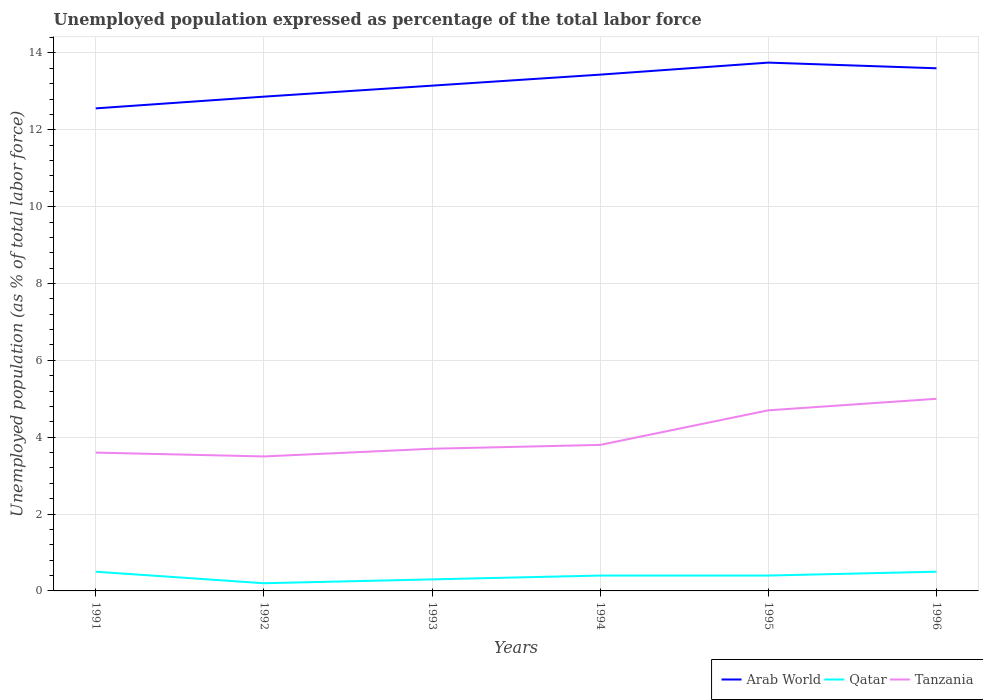How many different coloured lines are there?
Provide a short and direct response. 3. Across all years, what is the maximum unemployment in in Tanzania?
Provide a short and direct response. 3.5. In which year was the unemployment in in Tanzania maximum?
Your answer should be very brief. 1992. What is the total unemployment in in Tanzania in the graph?
Your answer should be compact. 0.1. What is the difference between the highest and the second highest unemployment in in Qatar?
Your answer should be compact. 0.3. What is the difference between the highest and the lowest unemployment in in Arab World?
Your answer should be very brief. 3. Is the unemployment in in Tanzania strictly greater than the unemployment in in Qatar over the years?
Offer a very short reply. No. How many lines are there?
Keep it short and to the point. 3. What is the difference between two consecutive major ticks on the Y-axis?
Offer a very short reply. 2. Does the graph contain any zero values?
Your answer should be very brief. No. What is the title of the graph?
Keep it short and to the point. Unemployed population expressed as percentage of the total labor force. Does "Suriname" appear as one of the legend labels in the graph?
Offer a very short reply. No. What is the label or title of the Y-axis?
Provide a short and direct response. Unemployed population (as % of total labor force). What is the Unemployed population (as % of total labor force) of Arab World in 1991?
Provide a short and direct response. 12.56. What is the Unemployed population (as % of total labor force) in Qatar in 1991?
Offer a terse response. 0.5. What is the Unemployed population (as % of total labor force) in Tanzania in 1991?
Offer a very short reply. 3.6. What is the Unemployed population (as % of total labor force) of Arab World in 1992?
Provide a succinct answer. 12.86. What is the Unemployed population (as % of total labor force) of Qatar in 1992?
Your response must be concise. 0.2. What is the Unemployed population (as % of total labor force) in Arab World in 1993?
Offer a very short reply. 13.15. What is the Unemployed population (as % of total labor force) of Qatar in 1993?
Your response must be concise. 0.3. What is the Unemployed population (as % of total labor force) in Tanzania in 1993?
Give a very brief answer. 3.7. What is the Unemployed population (as % of total labor force) in Arab World in 1994?
Keep it short and to the point. 13.44. What is the Unemployed population (as % of total labor force) in Qatar in 1994?
Offer a very short reply. 0.4. What is the Unemployed population (as % of total labor force) of Tanzania in 1994?
Your answer should be compact. 3.8. What is the Unemployed population (as % of total labor force) in Arab World in 1995?
Provide a short and direct response. 13.75. What is the Unemployed population (as % of total labor force) in Qatar in 1995?
Your response must be concise. 0.4. What is the Unemployed population (as % of total labor force) of Tanzania in 1995?
Your response must be concise. 4.7. What is the Unemployed population (as % of total labor force) of Arab World in 1996?
Offer a terse response. 13.6. What is the Unemployed population (as % of total labor force) of Qatar in 1996?
Provide a succinct answer. 0.5. Across all years, what is the maximum Unemployed population (as % of total labor force) in Arab World?
Ensure brevity in your answer.  13.75. Across all years, what is the maximum Unemployed population (as % of total labor force) of Qatar?
Provide a succinct answer. 0.5. Across all years, what is the maximum Unemployed population (as % of total labor force) of Tanzania?
Keep it short and to the point. 5. Across all years, what is the minimum Unemployed population (as % of total labor force) of Arab World?
Offer a terse response. 12.56. Across all years, what is the minimum Unemployed population (as % of total labor force) in Qatar?
Keep it short and to the point. 0.2. Across all years, what is the minimum Unemployed population (as % of total labor force) in Tanzania?
Give a very brief answer. 3.5. What is the total Unemployed population (as % of total labor force) in Arab World in the graph?
Your answer should be very brief. 79.36. What is the total Unemployed population (as % of total labor force) in Qatar in the graph?
Offer a very short reply. 2.3. What is the total Unemployed population (as % of total labor force) in Tanzania in the graph?
Provide a succinct answer. 24.3. What is the difference between the Unemployed population (as % of total labor force) in Arab World in 1991 and that in 1992?
Provide a short and direct response. -0.31. What is the difference between the Unemployed population (as % of total labor force) in Qatar in 1991 and that in 1992?
Ensure brevity in your answer.  0.3. What is the difference between the Unemployed population (as % of total labor force) in Tanzania in 1991 and that in 1992?
Ensure brevity in your answer.  0.1. What is the difference between the Unemployed population (as % of total labor force) of Arab World in 1991 and that in 1993?
Your answer should be compact. -0.59. What is the difference between the Unemployed population (as % of total labor force) of Qatar in 1991 and that in 1993?
Your response must be concise. 0.2. What is the difference between the Unemployed population (as % of total labor force) of Tanzania in 1991 and that in 1993?
Give a very brief answer. -0.1. What is the difference between the Unemployed population (as % of total labor force) in Arab World in 1991 and that in 1994?
Offer a very short reply. -0.88. What is the difference between the Unemployed population (as % of total labor force) in Tanzania in 1991 and that in 1994?
Your response must be concise. -0.2. What is the difference between the Unemployed population (as % of total labor force) in Arab World in 1991 and that in 1995?
Offer a terse response. -1.19. What is the difference between the Unemployed population (as % of total labor force) of Arab World in 1991 and that in 1996?
Make the answer very short. -1.04. What is the difference between the Unemployed population (as % of total labor force) in Arab World in 1992 and that in 1993?
Offer a very short reply. -0.29. What is the difference between the Unemployed population (as % of total labor force) in Tanzania in 1992 and that in 1993?
Make the answer very short. -0.2. What is the difference between the Unemployed population (as % of total labor force) of Arab World in 1992 and that in 1994?
Your response must be concise. -0.57. What is the difference between the Unemployed population (as % of total labor force) in Tanzania in 1992 and that in 1994?
Ensure brevity in your answer.  -0.3. What is the difference between the Unemployed population (as % of total labor force) in Arab World in 1992 and that in 1995?
Your response must be concise. -0.89. What is the difference between the Unemployed population (as % of total labor force) in Arab World in 1992 and that in 1996?
Give a very brief answer. -0.74. What is the difference between the Unemployed population (as % of total labor force) of Qatar in 1992 and that in 1996?
Your response must be concise. -0.3. What is the difference between the Unemployed population (as % of total labor force) of Tanzania in 1992 and that in 1996?
Provide a short and direct response. -1.5. What is the difference between the Unemployed population (as % of total labor force) in Arab World in 1993 and that in 1994?
Ensure brevity in your answer.  -0.29. What is the difference between the Unemployed population (as % of total labor force) in Qatar in 1993 and that in 1994?
Offer a terse response. -0.1. What is the difference between the Unemployed population (as % of total labor force) in Tanzania in 1993 and that in 1994?
Offer a very short reply. -0.1. What is the difference between the Unemployed population (as % of total labor force) of Arab World in 1993 and that in 1995?
Ensure brevity in your answer.  -0.6. What is the difference between the Unemployed population (as % of total labor force) of Qatar in 1993 and that in 1995?
Provide a succinct answer. -0.1. What is the difference between the Unemployed population (as % of total labor force) in Arab World in 1993 and that in 1996?
Your response must be concise. -0.45. What is the difference between the Unemployed population (as % of total labor force) of Arab World in 1994 and that in 1995?
Offer a terse response. -0.31. What is the difference between the Unemployed population (as % of total labor force) of Qatar in 1994 and that in 1995?
Your response must be concise. 0. What is the difference between the Unemployed population (as % of total labor force) of Arab World in 1994 and that in 1996?
Keep it short and to the point. -0.17. What is the difference between the Unemployed population (as % of total labor force) of Qatar in 1994 and that in 1996?
Ensure brevity in your answer.  -0.1. What is the difference between the Unemployed population (as % of total labor force) of Arab World in 1995 and that in 1996?
Your response must be concise. 0.15. What is the difference between the Unemployed population (as % of total labor force) of Qatar in 1995 and that in 1996?
Your answer should be very brief. -0.1. What is the difference between the Unemployed population (as % of total labor force) of Tanzania in 1995 and that in 1996?
Offer a terse response. -0.3. What is the difference between the Unemployed population (as % of total labor force) in Arab World in 1991 and the Unemployed population (as % of total labor force) in Qatar in 1992?
Provide a succinct answer. 12.36. What is the difference between the Unemployed population (as % of total labor force) in Arab World in 1991 and the Unemployed population (as % of total labor force) in Tanzania in 1992?
Provide a succinct answer. 9.06. What is the difference between the Unemployed population (as % of total labor force) of Qatar in 1991 and the Unemployed population (as % of total labor force) of Tanzania in 1992?
Your response must be concise. -3. What is the difference between the Unemployed population (as % of total labor force) of Arab World in 1991 and the Unemployed population (as % of total labor force) of Qatar in 1993?
Keep it short and to the point. 12.26. What is the difference between the Unemployed population (as % of total labor force) in Arab World in 1991 and the Unemployed population (as % of total labor force) in Tanzania in 1993?
Ensure brevity in your answer.  8.86. What is the difference between the Unemployed population (as % of total labor force) of Qatar in 1991 and the Unemployed population (as % of total labor force) of Tanzania in 1993?
Your response must be concise. -3.2. What is the difference between the Unemployed population (as % of total labor force) of Arab World in 1991 and the Unemployed population (as % of total labor force) of Qatar in 1994?
Keep it short and to the point. 12.16. What is the difference between the Unemployed population (as % of total labor force) in Arab World in 1991 and the Unemployed population (as % of total labor force) in Tanzania in 1994?
Ensure brevity in your answer.  8.76. What is the difference between the Unemployed population (as % of total labor force) in Qatar in 1991 and the Unemployed population (as % of total labor force) in Tanzania in 1994?
Offer a terse response. -3.3. What is the difference between the Unemployed population (as % of total labor force) in Arab World in 1991 and the Unemployed population (as % of total labor force) in Qatar in 1995?
Provide a succinct answer. 12.16. What is the difference between the Unemployed population (as % of total labor force) of Arab World in 1991 and the Unemployed population (as % of total labor force) of Tanzania in 1995?
Give a very brief answer. 7.86. What is the difference between the Unemployed population (as % of total labor force) of Qatar in 1991 and the Unemployed population (as % of total labor force) of Tanzania in 1995?
Your response must be concise. -4.2. What is the difference between the Unemployed population (as % of total labor force) in Arab World in 1991 and the Unemployed population (as % of total labor force) in Qatar in 1996?
Provide a succinct answer. 12.06. What is the difference between the Unemployed population (as % of total labor force) in Arab World in 1991 and the Unemployed population (as % of total labor force) in Tanzania in 1996?
Your answer should be compact. 7.56. What is the difference between the Unemployed population (as % of total labor force) in Arab World in 1992 and the Unemployed population (as % of total labor force) in Qatar in 1993?
Keep it short and to the point. 12.56. What is the difference between the Unemployed population (as % of total labor force) in Arab World in 1992 and the Unemployed population (as % of total labor force) in Tanzania in 1993?
Provide a short and direct response. 9.16. What is the difference between the Unemployed population (as % of total labor force) of Qatar in 1992 and the Unemployed population (as % of total labor force) of Tanzania in 1993?
Ensure brevity in your answer.  -3.5. What is the difference between the Unemployed population (as % of total labor force) of Arab World in 1992 and the Unemployed population (as % of total labor force) of Qatar in 1994?
Provide a succinct answer. 12.46. What is the difference between the Unemployed population (as % of total labor force) of Arab World in 1992 and the Unemployed population (as % of total labor force) of Tanzania in 1994?
Your answer should be very brief. 9.06. What is the difference between the Unemployed population (as % of total labor force) of Qatar in 1992 and the Unemployed population (as % of total labor force) of Tanzania in 1994?
Provide a short and direct response. -3.6. What is the difference between the Unemployed population (as % of total labor force) in Arab World in 1992 and the Unemployed population (as % of total labor force) in Qatar in 1995?
Give a very brief answer. 12.46. What is the difference between the Unemployed population (as % of total labor force) in Arab World in 1992 and the Unemployed population (as % of total labor force) in Tanzania in 1995?
Provide a short and direct response. 8.16. What is the difference between the Unemployed population (as % of total labor force) of Arab World in 1992 and the Unemployed population (as % of total labor force) of Qatar in 1996?
Offer a very short reply. 12.36. What is the difference between the Unemployed population (as % of total labor force) of Arab World in 1992 and the Unemployed population (as % of total labor force) of Tanzania in 1996?
Give a very brief answer. 7.86. What is the difference between the Unemployed population (as % of total labor force) in Arab World in 1993 and the Unemployed population (as % of total labor force) in Qatar in 1994?
Ensure brevity in your answer.  12.75. What is the difference between the Unemployed population (as % of total labor force) in Arab World in 1993 and the Unemployed population (as % of total labor force) in Tanzania in 1994?
Your answer should be compact. 9.35. What is the difference between the Unemployed population (as % of total labor force) in Qatar in 1993 and the Unemployed population (as % of total labor force) in Tanzania in 1994?
Provide a succinct answer. -3.5. What is the difference between the Unemployed population (as % of total labor force) in Arab World in 1993 and the Unemployed population (as % of total labor force) in Qatar in 1995?
Offer a terse response. 12.75. What is the difference between the Unemployed population (as % of total labor force) in Arab World in 1993 and the Unemployed population (as % of total labor force) in Tanzania in 1995?
Your response must be concise. 8.45. What is the difference between the Unemployed population (as % of total labor force) in Qatar in 1993 and the Unemployed population (as % of total labor force) in Tanzania in 1995?
Make the answer very short. -4.4. What is the difference between the Unemployed population (as % of total labor force) in Arab World in 1993 and the Unemployed population (as % of total labor force) in Qatar in 1996?
Your answer should be compact. 12.65. What is the difference between the Unemployed population (as % of total labor force) in Arab World in 1993 and the Unemployed population (as % of total labor force) in Tanzania in 1996?
Offer a terse response. 8.15. What is the difference between the Unemployed population (as % of total labor force) of Arab World in 1994 and the Unemployed population (as % of total labor force) of Qatar in 1995?
Provide a succinct answer. 13.04. What is the difference between the Unemployed population (as % of total labor force) of Arab World in 1994 and the Unemployed population (as % of total labor force) of Tanzania in 1995?
Provide a succinct answer. 8.74. What is the difference between the Unemployed population (as % of total labor force) of Qatar in 1994 and the Unemployed population (as % of total labor force) of Tanzania in 1995?
Provide a short and direct response. -4.3. What is the difference between the Unemployed population (as % of total labor force) in Arab World in 1994 and the Unemployed population (as % of total labor force) in Qatar in 1996?
Keep it short and to the point. 12.94. What is the difference between the Unemployed population (as % of total labor force) in Arab World in 1994 and the Unemployed population (as % of total labor force) in Tanzania in 1996?
Keep it short and to the point. 8.44. What is the difference between the Unemployed population (as % of total labor force) in Arab World in 1995 and the Unemployed population (as % of total labor force) in Qatar in 1996?
Your response must be concise. 13.25. What is the difference between the Unemployed population (as % of total labor force) in Arab World in 1995 and the Unemployed population (as % of total labor force) in Tanzania in 1996?
Make the answer very short. 8.75. What is the difference between the Unemployed population (as % of total labor force) in Qatar in 1995 and the Unemployed population (as % of total labor force) in Tanzania in 1996?
Your answer should be compact. -4.6. What is the average Unemployed population (as % of total labor force) in Arab World per year?
Keep it short and to the point. 13.23. What is the average Unemployed population (as % of total labor force) of Qatar per year?
Your answer should be very brief. 0.38. What is the average Unemployed population (as % of total labor force) in Tanzania per year?
Offer a very short reply. 4.05. In the year 1991, what is the difference between the Unemployed population (as % of total labor force) in Arab World and Unemployed population (as % of total labor force) in Qatar?
Keep it short and to the point. 12.06. In the year 1991, what is the difference between the Unemployed population (as % of total labor force) in Arab World and Unemployed population (as % of total labor force) in Tanzania?
Give a very brief answer. 8.96. In the year 1992, what is the difference between the Unemployed population (as % of total labor force) in Arab World and Unemployed population (as % of total labor force) in Qatar?
Ensure brevity in your answer.  12.66. In the year 1992, what is the difference between the Unemployed population (as % of total labor force) in Arab World and Unemployed population (as % of total labor force) in Tanzania?
Keep it short and to the point. 9.36. In the year 1992, what is the difference between the Unemployed population (as % of total labor force) of Qatar and Unemployed population (as % of total labor force) of Tanzania?
Offer a very short reply. -3.3. In the year 1993, what is the difference between the Unemployed population (as % of total labor force) in Arab World and Unemployed population (as % of total labor force) in Qatar?
Ensure brevity in your answer.  12.85. In the year 1993, what is the difference between the Unemployed population (as % of total labor force) of Arab World and Unemployed population (as % of total labor force) of Tanzania?
Your answer should be compact. 9.45. In the year 1993, what is the difference between the Unemployed population (as % of total labor force) of Qatar and Unemployed population (as % of total labor force) of Tanzania?
Your answer should be very brief. -3.4. In the year 1994, what is the difference between the Unemployed population (as % of total labor force) of Arab World and Unemployed population (as % of total labor force) of Qatar?
Offer a terse response. 13.04. In the year 1994, what is the difference between the Unemployed population (as % of total labor force) of Arab World and Unemployed population (as % of total labor force) of Tanzania?
Provide a succinct answer. 9.64. In the year 1994, what is the difference between the Unemployed population (as % of total labor force) of Qatar and Unemployed population (as % of total labor force) of Tanzania?
Provide a succinct answer. -3.4. In the year 1995, what is the difference between the Unemployed population (as % of total labor force) of Arab World and Unemployed population (as % of total labor force) of Qatar?
Provide a succinct answer. 13.35. In the year 1995, what is the difference between the Unemployed population (as % of total labor force) of Arab World and Unemployed population (as % of total labor force) of Tanzania?
Provide a short and direct response. 9.05. In the year 1995, what is the difference between the Unemployed population (as % of total labor force) of Qatar and Unemployed population (as % of total labor force) of Tanzania?
Provide a succinct answer. -4.3. In the year 1996, what is the difference between the Unemployed population (as % of total labor force) in Arab World and Unemployed population (as % of total labor force) in Qatar?
Provide a succinct answer. 13.1. In the year 1996, what is the difference between the Unemployed population (as % of total labor force) of Arab World and Unemployed population (as % of total labor force) of Tanzania?
Your response must be concise. 8.6. What is the ratio of the Unemployed population (as % of total labor force) in Arab World in 1991 to that in 1992?
Keep it short and to the point. 0.98. What is the ratio of the Unemployed population (as % of total labor force) in Tanzania in 1991 to that in 1992?
Your response must be concise. 1.03. What is the ratio of the Unemployed population (as % of total labor force) in Arab World in 1991 to that in 1993?
Ensure brevity in your answer.  0.95. What is the ratio of the Unemployed population (as % of total labor force) in Tanzania in 1991 to that in 1993?
Keep it short and to the point. 0.97. What is the ratio of the Unemployed population (as % of total labor force) of Arab World in 1991 to that in 1994?
Offer a terse response. 0.93. What is the ratio of the Unemployed population (as % of total labor force) in Tanzania in 1991 to that in 1994?
Keep it short and to the point. 0.95. What is the ratio of the Unemployed population (as % of total labor force) in Arab World in 1991 to that in 1995?
Provide a short and direct response. 0.91. What is the ratio of the Unemployed population (as % of total labor force) in Qatar in 1991 to that in 1995?
Your answer should be very brief. 1.25. What is the ratio of the Unemployed population (as % of total labor force) in Tanzania in 1991 to that in 1995?
Provide a succinct answer. 0.77. What is the ratio of the Unemployed population (as % of total labor force) of Arab World in 1991 to that in 1996?
Make the answer very short. 0.92. What is the ratio of the Unemployed population (as % of total labor force) of Tanzania in 1991 to that in 1996?
Keep it short and to the point. 0.72. What is the ratio of the Unemployed population (as % of total labor force) in Arab World in 1992 to that in 1993?
Keep it short and to the point. 0.98. What is the ratio of the Unemployed population (as % of total labor force) of Qatar in 1992 to that in 1993?
Provide a succinct answer. 0.67. What is the ratio of the Unemployed population (as % of total labor force) of Tanzania in 1992 to that in 1993?
Your response must be concise. 0.95. What is the ratio of the Unemployed population (as % of total labor force) in Arab World in 1992 to that in 1994?
Provide a succinct answer. 0.96. What is the ratio of the Unemployed population (as % of total labor force) in Tanzania in 1992 to that in 1994?
Your response must be concise. 0.92. What is the ratio of the Unemployed population (as % of total labor force) of Arab World in 1992 to that in 1995?
Provide a short and direct response. 0.94. What is the ratio of the Unemployed population (as % of total labor force) in Qatar in 1992 to that in 1995?
Offer a very short reply. 0.5. What is the ratio of the Unemployed population (as % of total labor force) of Tanzania in 1992 to that in 1995?
Your answer should be very brief. 0.74. What is the ratio of the Unemployed population (as % of total labor force) in Arab World in 1992 to that in 1996?
Ensure brevity in your answer.  0.95. What is the ratio of the Unemployed population (as % of total labor force) in Tanzania in 1992 to that in 1996?
Offer a very short reply. 0.7. What is the ratio of the Unemployed population (as % of total labor force) in Arab World in 1993 to that in 1994?
Your response must be concise. 0.98. What is the ratio of the Unemployed population (as % of total labor force) of Qatar in 1993 to that in 1994?
Your answer should be very brief. 0.75. What is the ratio of the Unemployed population (as % of total labor force) of Tanzania in 1993 to that in 1994?
Provide a succinct answer. 0.97. What is the ratio of the Unemployed population (as % of total labor force) in Arab World in 1993 to that in 1995?
Offer a terse response. 0.96. What is the ratio of the Unemployed population (as % of total labor force) of Qatar in 1993 to that in 1995?
Offer a very short reply. 0.75. What is the ratio of the Unemployed population (as % of total labor force) of Tanzania in 1993 to that in 1995?
Provide a succinct answer. 0.79. What is the ratio of the Unemployed population (as % of total labor force) of Arab World in 1993 to that in 1996?
Provide a succinct answer. 0.97. What is the ratio of the Unemployed population (as % of total labor force) in Qatar in 1993 to that in 1996?
Provide a short and direct response. 0.6. What is the ratio of the Unemployed population (as % of total labor force) in Tanzania in 1993 to that in 1996?
Your answer should be compact. 0.74. What is the ratio of the Unemployed population (as % of total labor force) of Arab World in 1994 to that in 1995?
Give a very brief answer. 0.98. What is the ratio of the Unemployed population (as % of total labor force) in Tanzania in 1994 to that in 1995?
Give a very brief answer. 0.81. What is the ratio of the Unemployed population (as % of total labor force) in Tanzania in 1994 to that in 1996?
Give a very brief answer. 0.76. What is the ratio of the Unemployed population (as % of total labor force) of Arab World in 1995 to that in 1996?
Offer a very short reply. 1.01. What is the ratio of the Unemployed population (as % of total labor force) in Qatar in 1995 to that in 1996?
Offer a very short reply. 0.8. What is the ratio of the Unemployed population (as % of total labor force) of Tanzania in 1995 to that in 1996?
Your answer should be very brief. 0.94. What is the difference between the highest and the second highest Unemployed population (as % of total labor force) of Arab World?
Provide a succinct answer. 0.15. What is the difference between the highest and the lowest Unemployed population (as % of total labor force) of Arab World?
Provide a short and direct response. 1.19. 